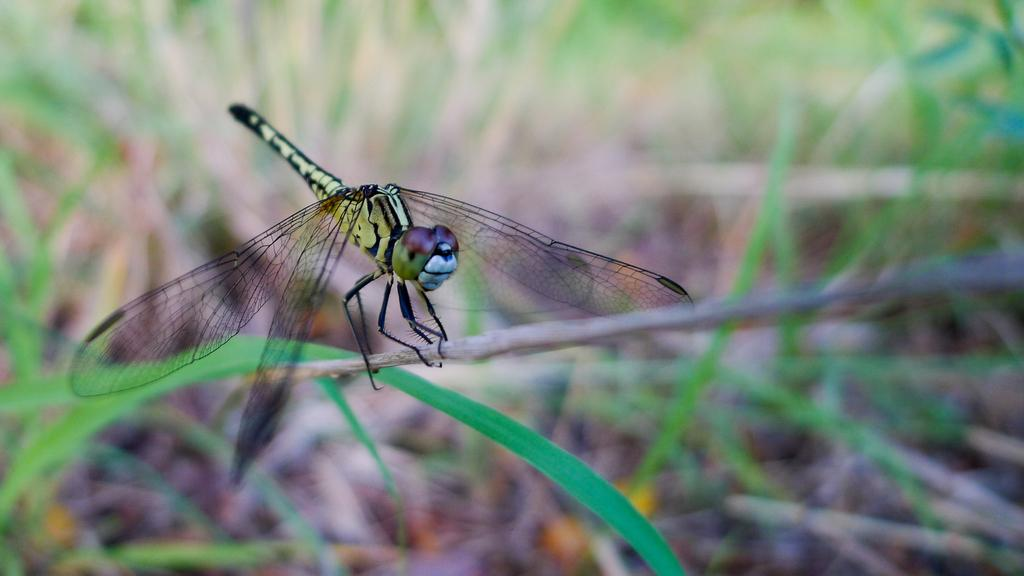What type of insect is present in the image? There is a dragonfly in the image. Where is the dragonfly located in the image? The dragonfly is on steam in the image. What type of trail can be seen in the image? There is no trail present in the image; it features a dragonfly on steam. What color is the flame in the image? There is no flame present in the image; it features a dragonfly on steam. 